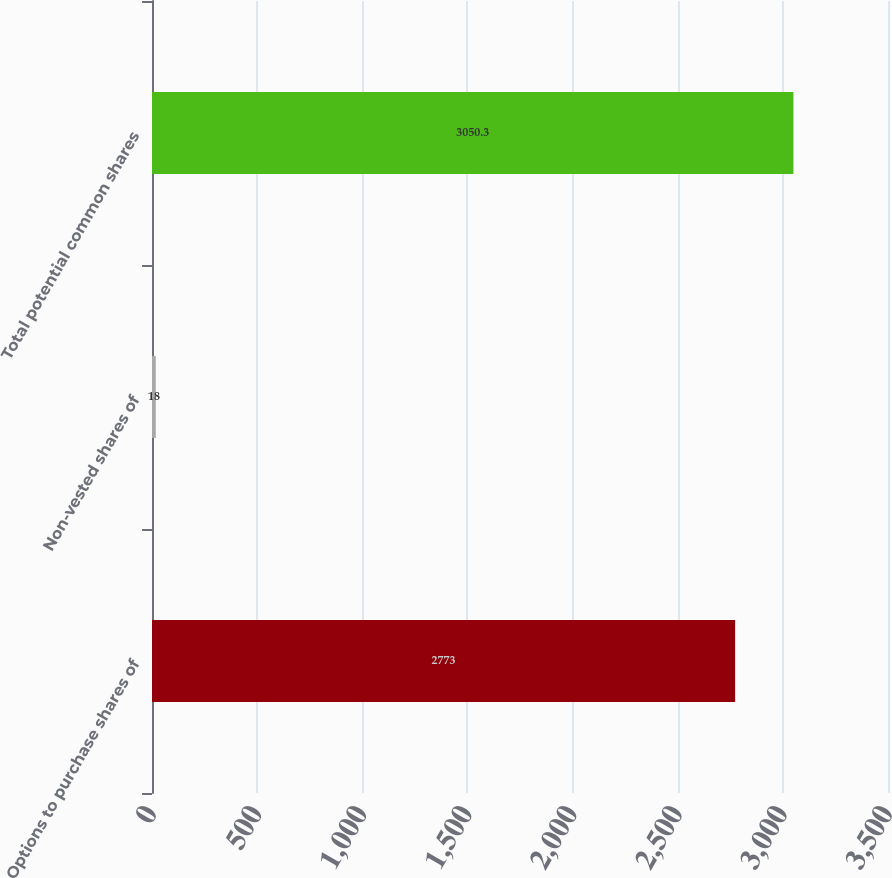Convert chart. <chart><loc_0><loc_0><loc_500><loc_500><bar_chart><fcel>Options to purchase shares of<fcel>Non-vested shares of<fcel>Total potential common shares<nl><fcel>2773<fcel>18<fcel>3050.3<nl></chart> 